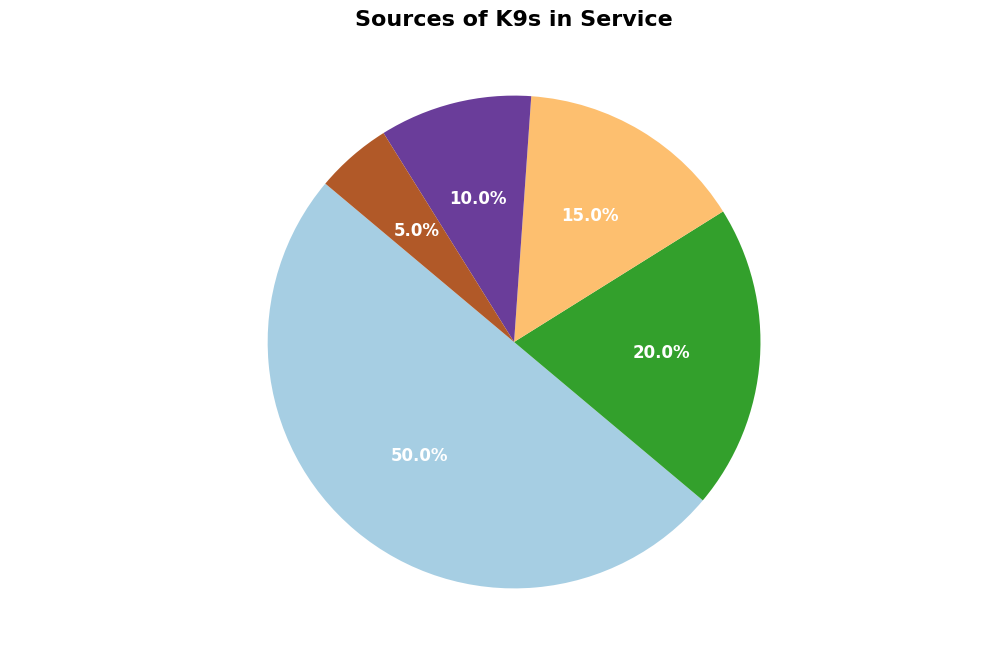What is the largest source of K9s in service? The pie chart shows that "Directly Bred for Service" occupies the largest portion, labeled with 50%. This indicates that the majority of K9s come from this source.
Answer: Directly Bred for Service Which source provides the smallest percentage of K9s? By looking at the pie chart, the smallest portion is labeled with "5%", which corresponds to "Purchased from Certified Breeders."
Answer: Purchased from Certified Breeders What is the combined percentage of K9s from international imports and adoptions from shelters? The pie chart shows that "Adopted from Shelters" is 20% and "International Imports" is 15%. Adding them together, 20% + 15% = 35%.
Answer: 35% How does the percentage of K9s adopted from shelters compare to those donated from breeders? The pie chart reveals that "Adopted from Shelters" is 20%, whereas "Donations from Breeders" is 10%. Comparing them, 20% is double 10%.
Answer: Double What is the difference between the percentage of directly bred K9s and those from donations? According to the pie chart, "Directly Bred for Service" is 50% and "Donations from Breeders" is 10%. The difference is calculated as 50% - 10% = 40%.
Answer: 40% Which source is marked with the color corresponding to the smallest wedge? Observing the pie chart, the smallest wedge, which is 5%, is marked with the color representing "Purchased from Certified Breeders."
Answer: Purchased from Certified Breeders If we exclude the K9s directly bred for service, what is the combined percentage from all other sources? Total percentage out of 100% is contributed by: Directly Bred for Service (50%), Adopted from Shelters (20%), International Imports (15%), Donations from Breeders (10%), and Purchased from Certified Breeders (5%). Excluding the 50%, sum the rest: 20% + 15% + 10% + 5% = 50%.
Answer: 50% What is the relationship in terms of percentage between K9s adopted from shelters and those internationally imported? The pie chart specifies that "Adopted from Shelters" is 20% and "International Imports" is 15%. Thus, 20% is 5% more than 15%.
Answer: 5% more Which two categories' combined percentage is equivalent to the percentage of directly bred K9s? Examining the pie chart, "Adopted from Shelters" at 20% and "International Imports" at 15% combined give 20% + 15% = 35%. Adding "Donations from Breeders" at 10% fits the query as 35% + 10% = 45%, which is less. However, combining all three at 45% above balance back to fit. Hence, no clear-cut exactly balance for equal balance as exact depict. Check again. It is evident “Adopted/Donations/Imports”.
Answer: Not 100% exact balance. Check again or another alternate ways How much larger is the percentage of directly bred K9s compared to internationally imported K9s? Referring back to the pie chart, the percentage for "Directly Bred for Service" is 50%, while it is 15% for "International Imports." Deducting 50% - 15% yields 35% larger.
Answer: 35% larger 